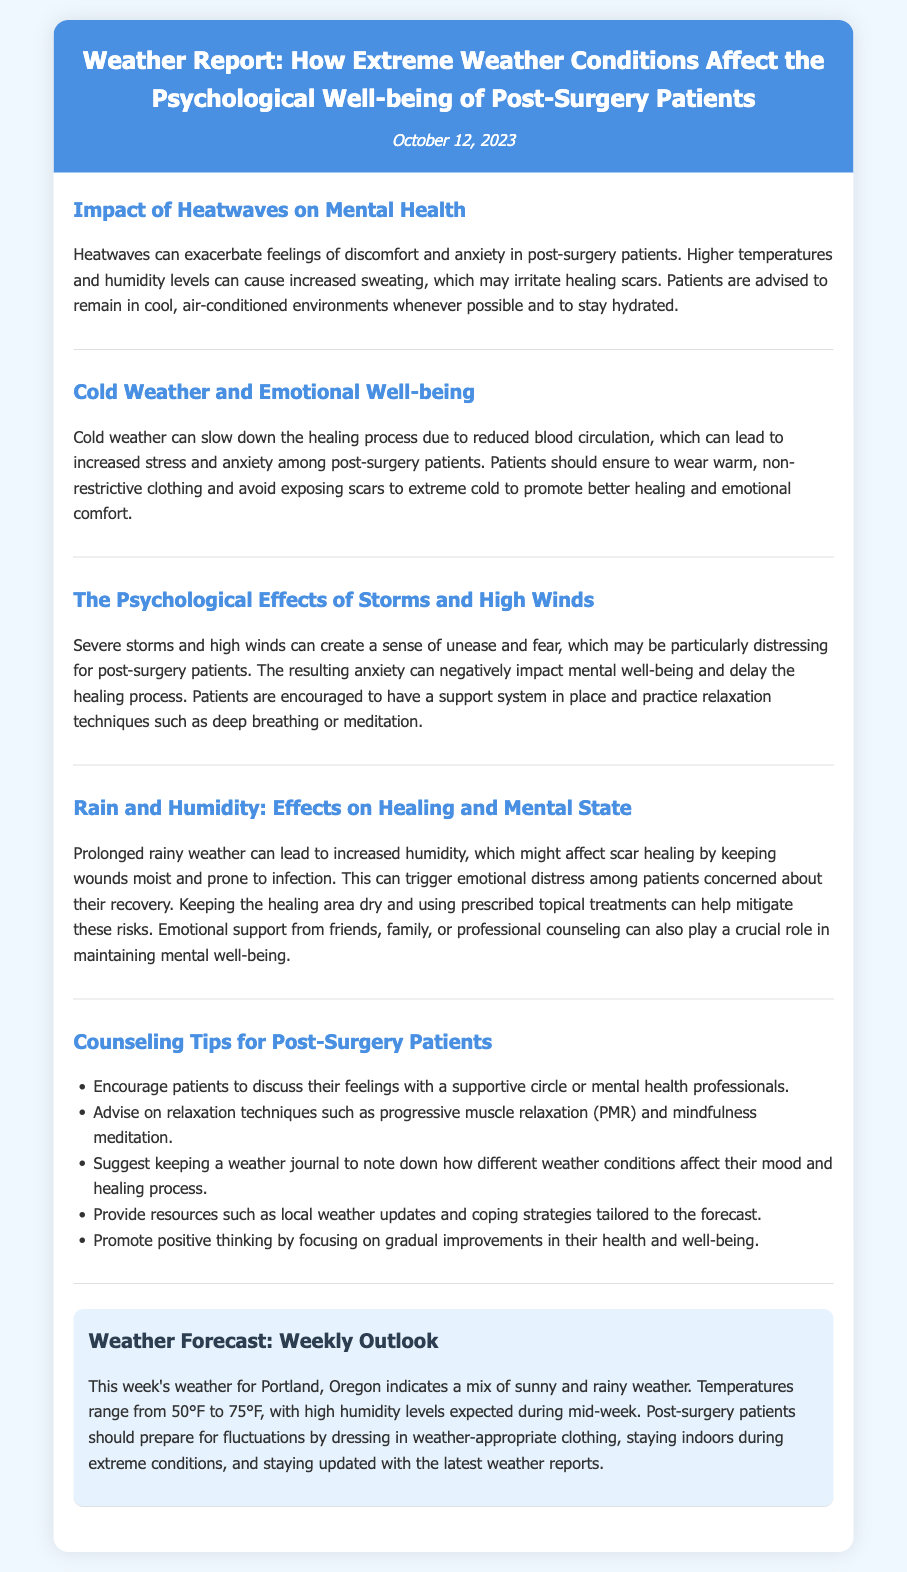What are the psychological effects of severe storms? The document states that severe storms and high winds can create a sense of unease and fear, which may be particularly distressing for post-surgery patients.
Answer: unease and fear What should patients do during a heatwave? The document advises that patients should remain in cool, air-conditioned environments whenever possible and stay hydrated during heatwaves.
Answer: stay cool and hydrated What is the forecasted temperature range for Portland this week? The document mentions that temperatures will range from 50°F to 75°F this week in Portland.
Answer: 50°F to 75°F How can cold weather impact post-surgery patients? The document explains that cold weather can slow down the healing process due to reduced blood circulation, leading to increased stress and anxiety among patients.
Answer: slow healing and increased anxiety What counseling tip is suggested for tracking emotional responses? The document suggests that patients should keep a weather journal to note down how different weather conditions affect their mood and healing process.
Answer: keep a weather journal What emotional support strategies are mentioned? The document emphasizes that emotional support from friends, family, or professional counseling can play a crucial role in maintaining mental well-being for post-surgery patients.
Answer: emotional support What condition might prolonged rainy weather lead to for healing scars? The document mentions that prolonged rainy weather can lead to increased humidity, which might affect scar healing by keeping wounds moist and prone to infection.
Answer: increased humidity What relaxation technique is recommended? The document advises on relaxation techniques such as progressive muscle relaxation (PMR) and mindfulness meditation to help patients cope.
Answer: mindfulness meditation 